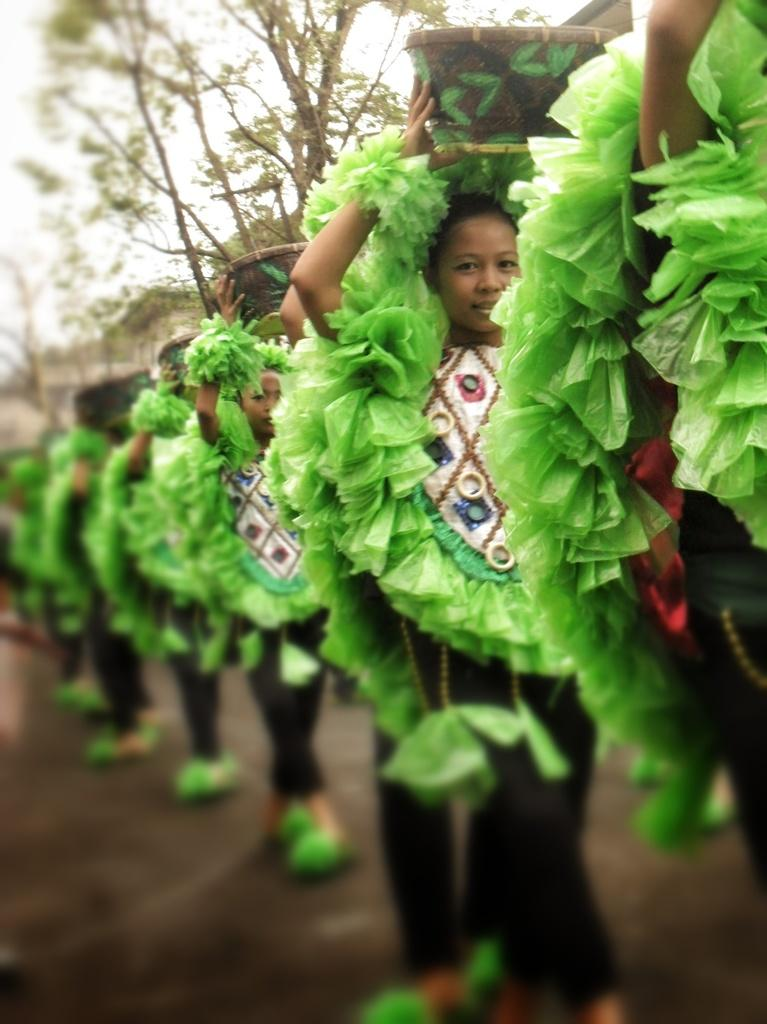What are the people in the image doing? The people in the image are standing and holding a basket. What can be seen in the background of the image? There are trees visible in the image. What is visible at the top of the image? The sky is visible in the image. What type of shoes are the people wearing in the image? There is no information about shoes in the image, as the focus is on the people holding a basket. 